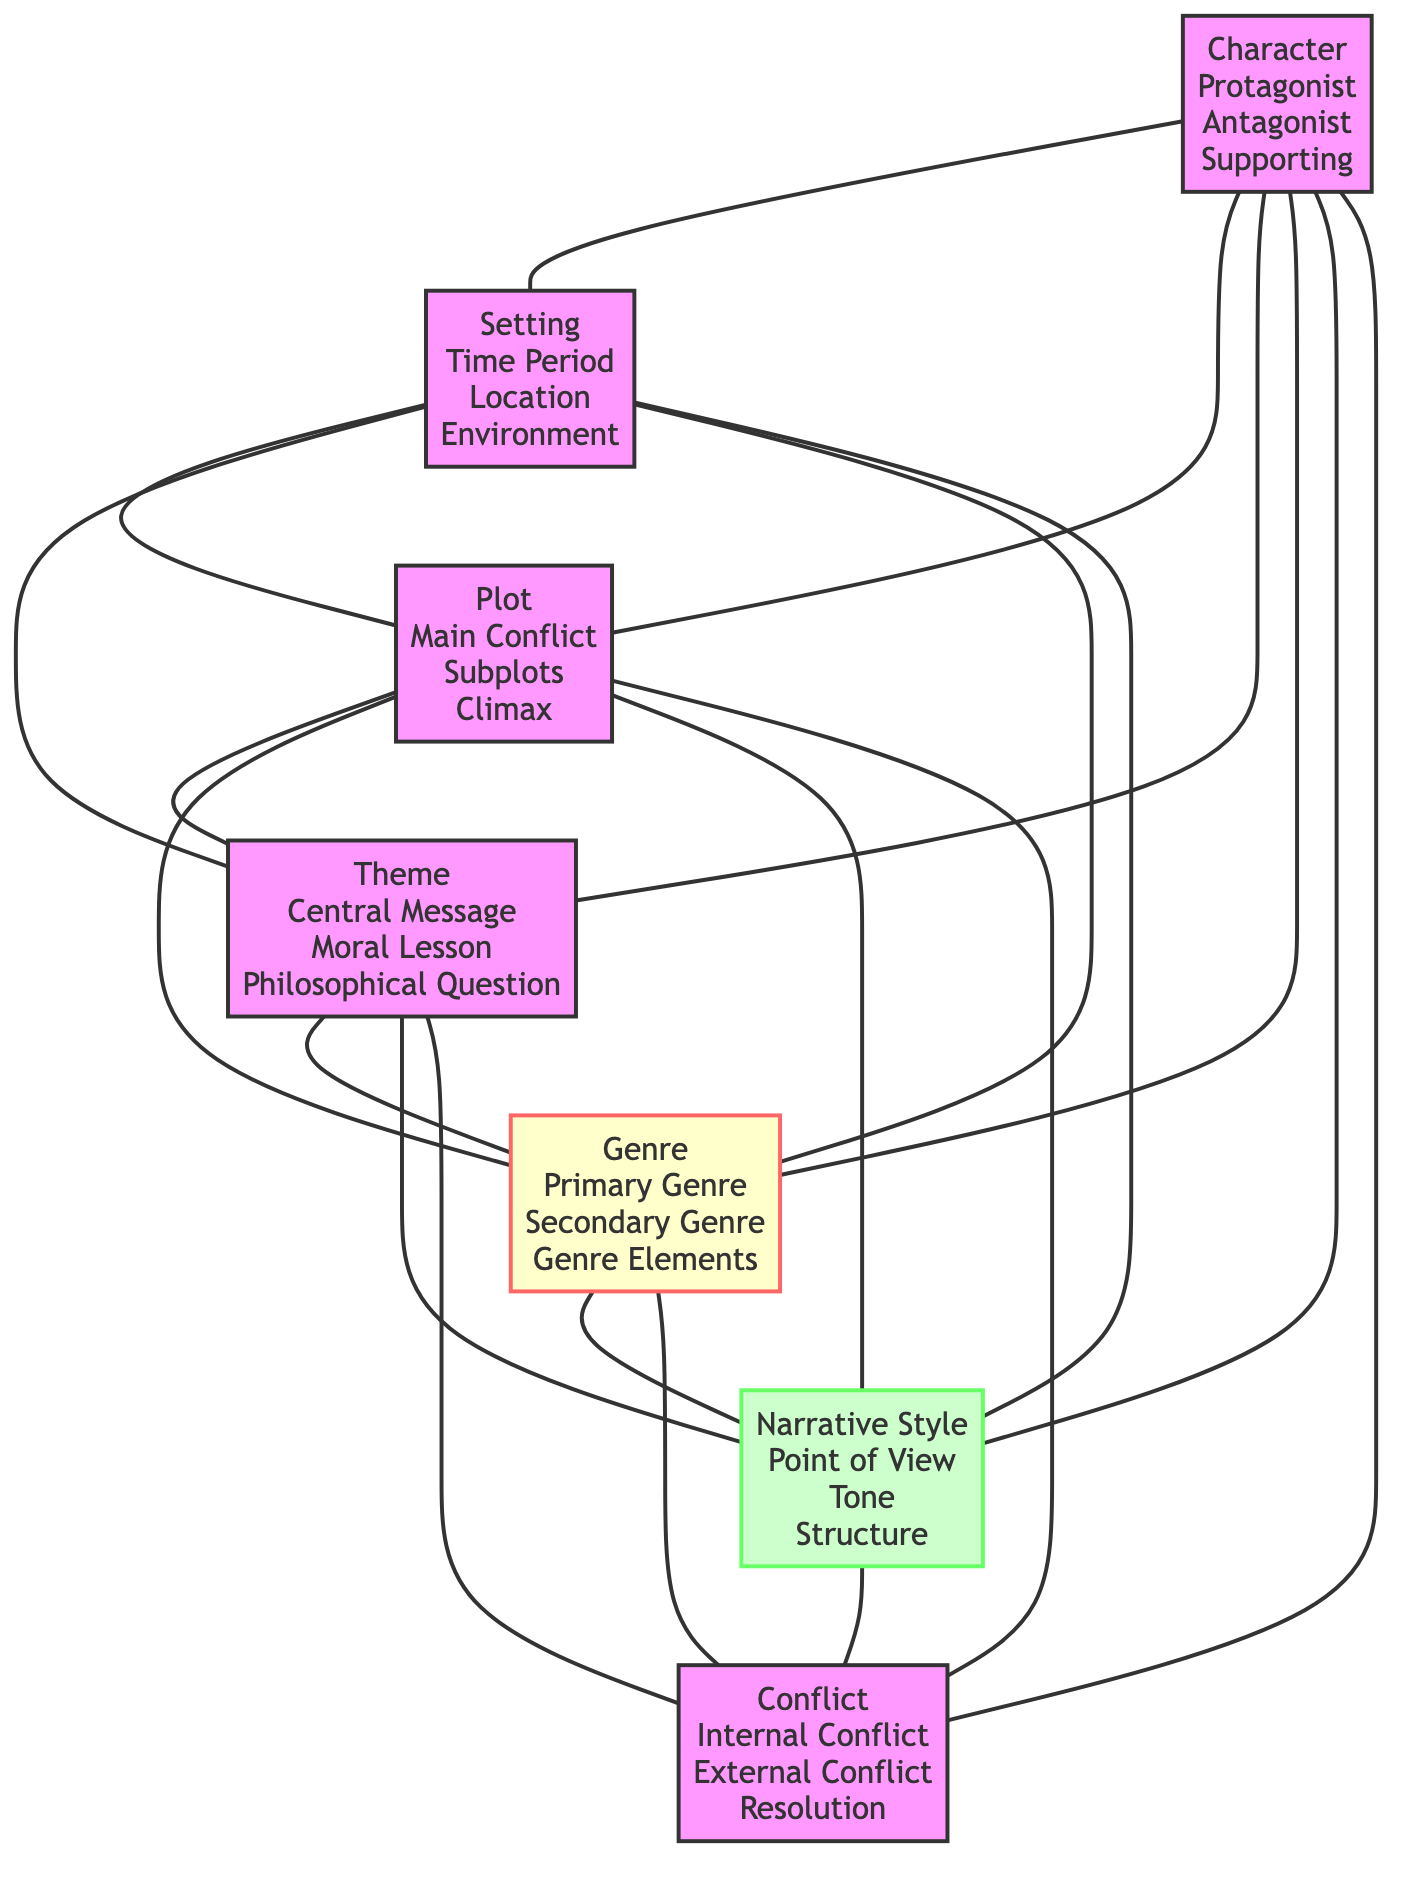What are the three attributes of "Character"? The diagram lists the attributes of "Character" as Protagonist, Antagonist, and Supporting. These attributes define the different roles characters can have in a story.
Answer: Protagonist, Antagonist, Supporting How many elements are connected to "Setting"? By examining the diagram, "Setting" has connections to "Character," "Plot," "Theme," "Genre," and "Narrative Style," making a total of five connections.
Answer: 5 What are the elements connected to "Plot"? The diagram shows that "Plot" is connected to "Character," "Setting," "Theme," "Genre," and "Conflict." These connections highlight the aspects that shape the plot of a story.
Answer: Character, Setting, Theme, Genre, Conflict Which two elements share the most connections? Looking closely at the diagram, "Character" and "Plot" both connect to six other elements each, which indicates they are central to the narrative structure in hybrid fiction.
Answer: Character, Plot What type of new theme could be explored by connecting "Theme" and "Genre"? The connection between "Theme" and "Genre" suggests that the central messages or moral lessons can be enriched or transformed depending on the genre elements being utilized. For example, combining Existentialism with Science Fiction.
Answer: Existentialism and Science Fiction Which attribute of "Conflict" deals with interpersonal struggles? The attribute "internal conflict" relates directly to interpersonal struggles within a character, capturing the essence of a character’s personal struggle as they face challenges.
Answer: Internal Conflict How do "Narrative Style" and "Genre" interact in this diagram? "Narrative Style" and "Genre" are connected, suggesting that the way a story is told (point of view, tone, or structure) is influenced by its genre, impacting the reader's engagement and the storytelling approach.
Answer: Narrative Style influences Genre How many edges are there in total between all connections? By analyzing the diagram, we can count a total of 16 edges connecting various elements together, representing the relationships present in a hybrid fiction novel's architectural framework.
Answer: 16 edges Which genre examples are listed under the "Genre" node? The diagram provides examples of genre as Science Fiction, Romance, and Mystery, showcasing the diverse possibilities for storytelling within hybrid fiction.
Answer: Science Fiction, Romance, Mystery 